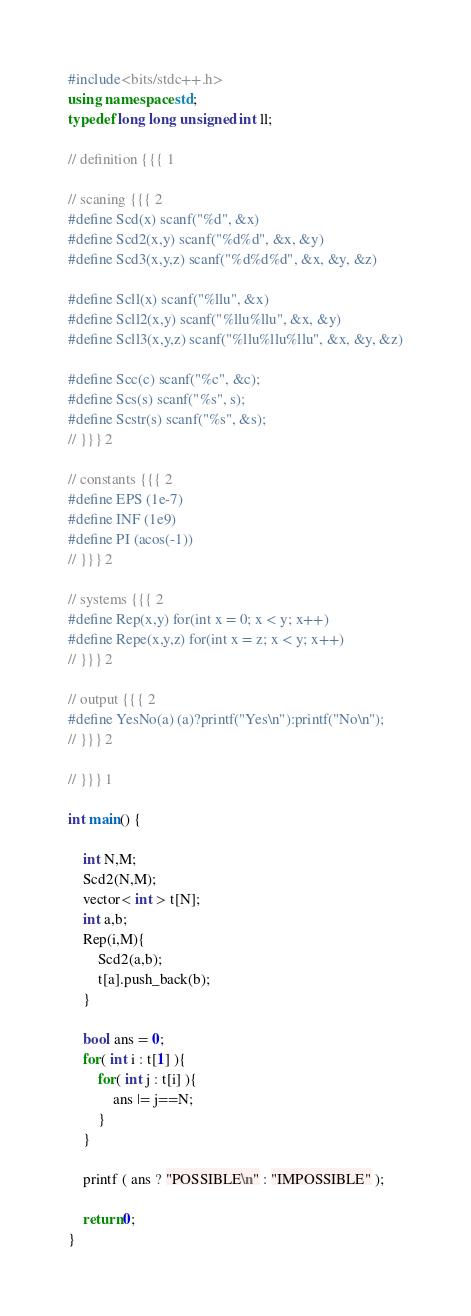<code> <loc_0><loc_0><loc_500><loc_500><_C++_>#include<bits/stdc++.h>
using namespace std;
typedef long long unsigned int ll;

// definition {{{ 1

// scaning {{{ 2
#define Scd(x) scanf("%d", &x)
#define Scd2(x,y) scanf("%d%d", &x, &y)
#define Scd3(x,y,z) scanf("%d%d%d", &x, &y, &z)

#define Scll(x) scanf("%llu", &x)
#define Scll2(x,y) scanf("%llu%llu", &x, &y)
#define Scll3(x,y,z) scanf("%llu%llu%llu", &x, &y, &z)

#define Scc(c) scanf("%c", &c);
#define Scs(s) scanf("%s", s);
#define Scstr(s) scanf("%s", &s);
// }}} 2

// constants {{{ 2
#define EPS (1e-7)
#define INF (1e9)
#define PI (acos(-1))
// }}} 2

// systems {{{ 2
#define Rep(x,y) for(int x = 0; x < y; x++)
#define Repe(x,y,z) for(int x = z; x < y; x++)
// }}} 2

// output {{{ 2
#define YesNo(a) (a)?printf("Yes\n"):printf("No\n");
// }}} 2

// }}} 1

int main() {

    int N,M;
    Scd2(N,M);
    vector< int > t[N];
    int a,b;
    Rep(i,M){
        Scd2(a,b);
        t[a].push_back(b);
    }

    bool ans = 0;
    for( int i : t[1] ){
        for( int j : t[i] ){
            ans |= j==N;
        }
    }

    printf ( ans ? "POSSIBLE\n" : "IMPOSSIBLE" );

    return 0;
}

</code> 